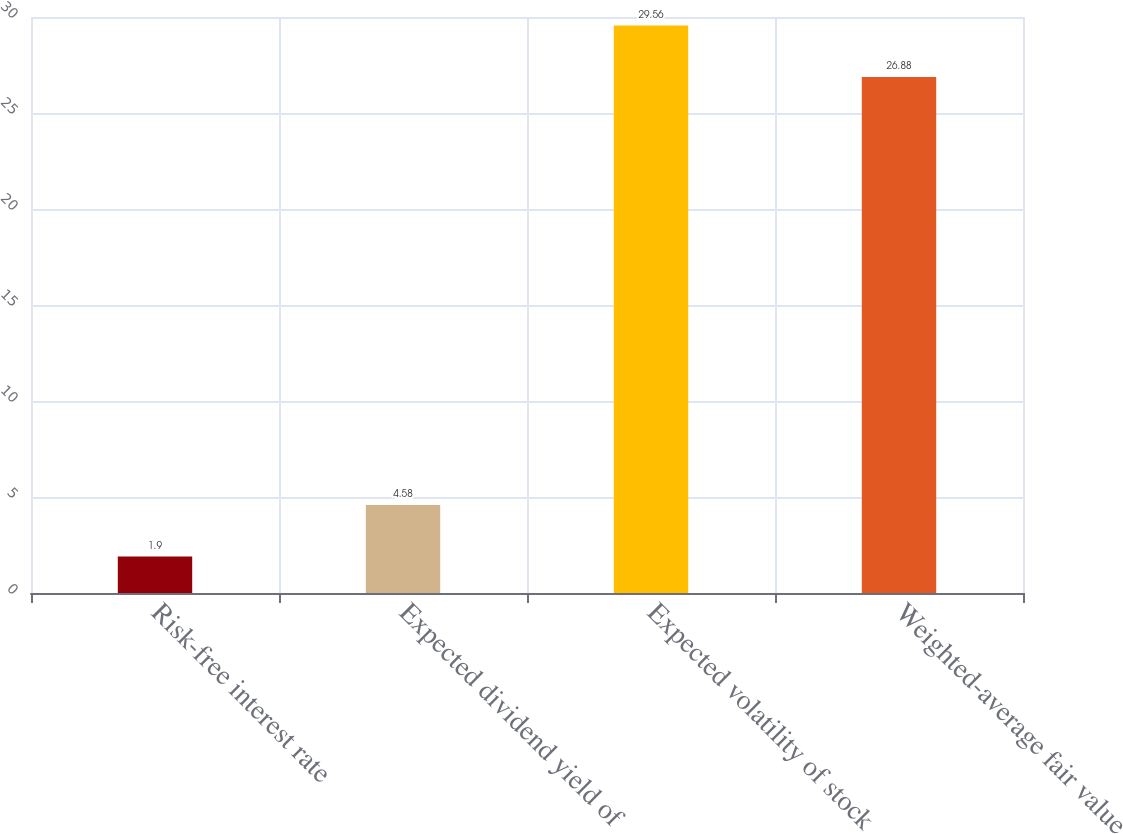Convert chart to OTSL. <chart><loc_0><loc_0><loc_500><loc_500><bar_chart><fcel>Risk-free interest rate<fcel>Expected dividend yield of<fcel>Expected volatility of stock<fcel>Weighted-average fair value<nl><fcel>1.9<fcel>4.58<fcel>29.56<fcel>26.88<nl></chart> 